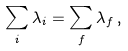<formula> <loc_0><loc_0><loc_500><loc_500>\sum _ { i } \lambda _ { i } = \sum _ { f } \lambda _ { f } \, ,</formula> 